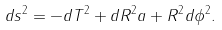Convert formula to latex. <formula><loc_0><loc_0><loc_500><loc_500>d s ^ { 2 } = - d T ^ { 2 } + d R ^ { 2 } a + R ^ { 2 } d \phi ^ { 2 } .</formula> 